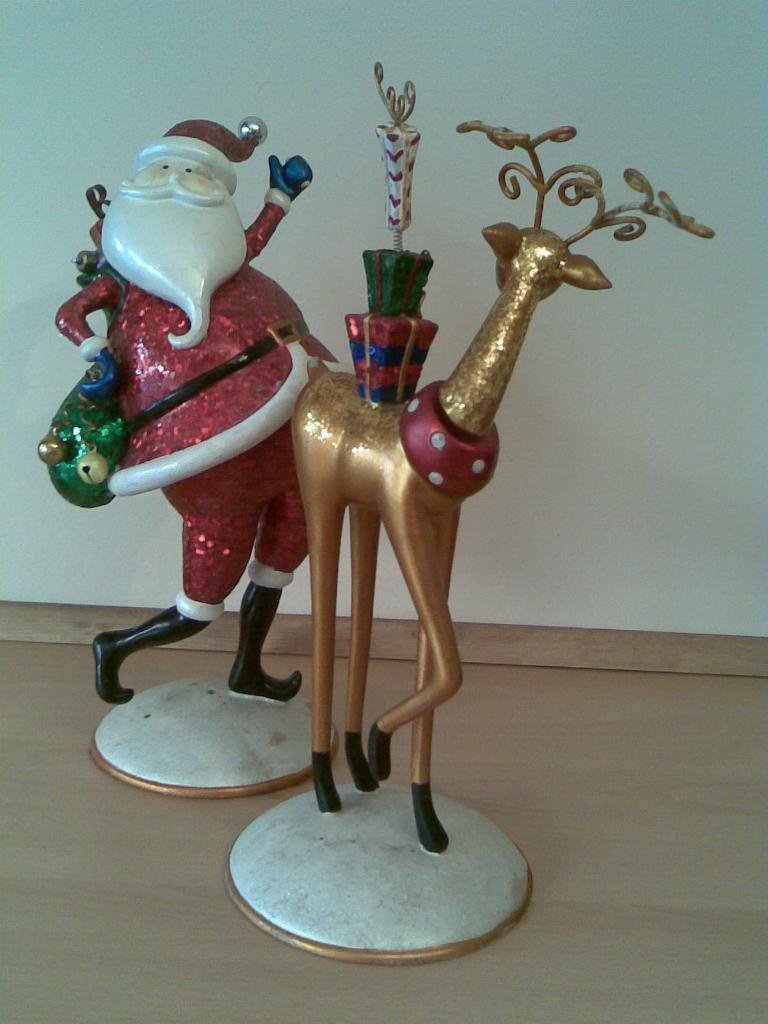How many toys are present in the image? There are two toys in the image. What are the colors of the toys in the image? One toy is red in color, and the other toy is golden in color. What type of street is visible in the image? There is no street present in the image; it only features two toys. What song is being played in the background of the image? There is no song playing in the background of the image, as it only features two toys. 